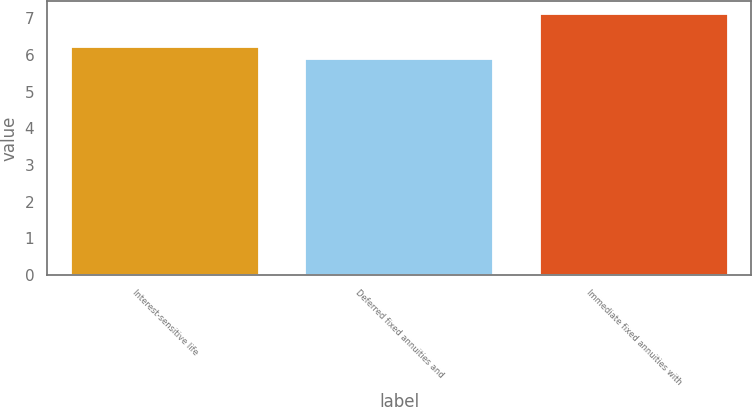Convert chart. <chart><loc_0><loc_0><loc_500><loc_500><bar_chart><fcel>Interest-sensitive life<fcel>Deferred fixed annuities and<fcel>Immediate fixed annuities with<nl><fcel>6.2<fcel>5.9<fcel>7.1<nl></chart> 